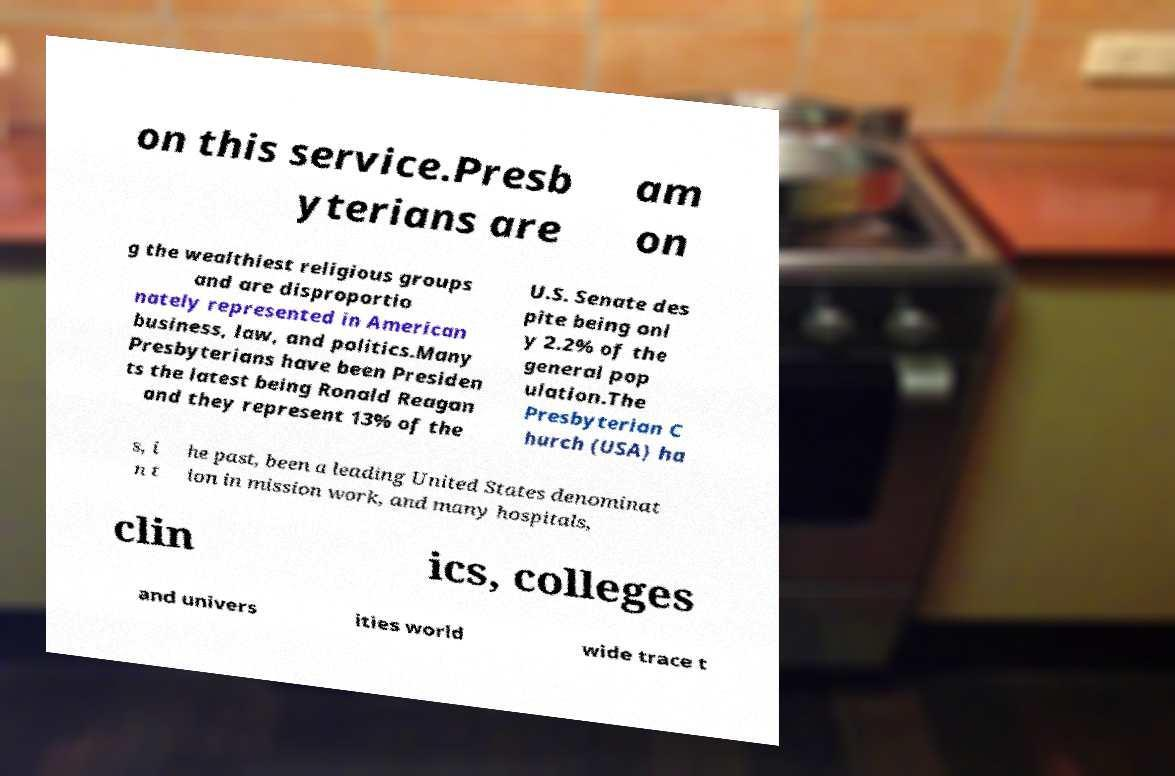Can you accurately transcribe the text from the provided image for me? on this service.Presb yterians are am on g the wealthiest religious groups and are disproportio nately represented in American business, law, and politics.Many Presbyterians have been Presiden ts the latest being Ronald Reagan and they represent 13% of the U.S. Senate des pite being onl y 2.2% of the general pop ulation.The Presbyterian C hurch (USA) ha s, i n t he past, been a leading United States denominat ion in mission work, and many hospitals, clin ics, colleges and univers ities world wide trace t 